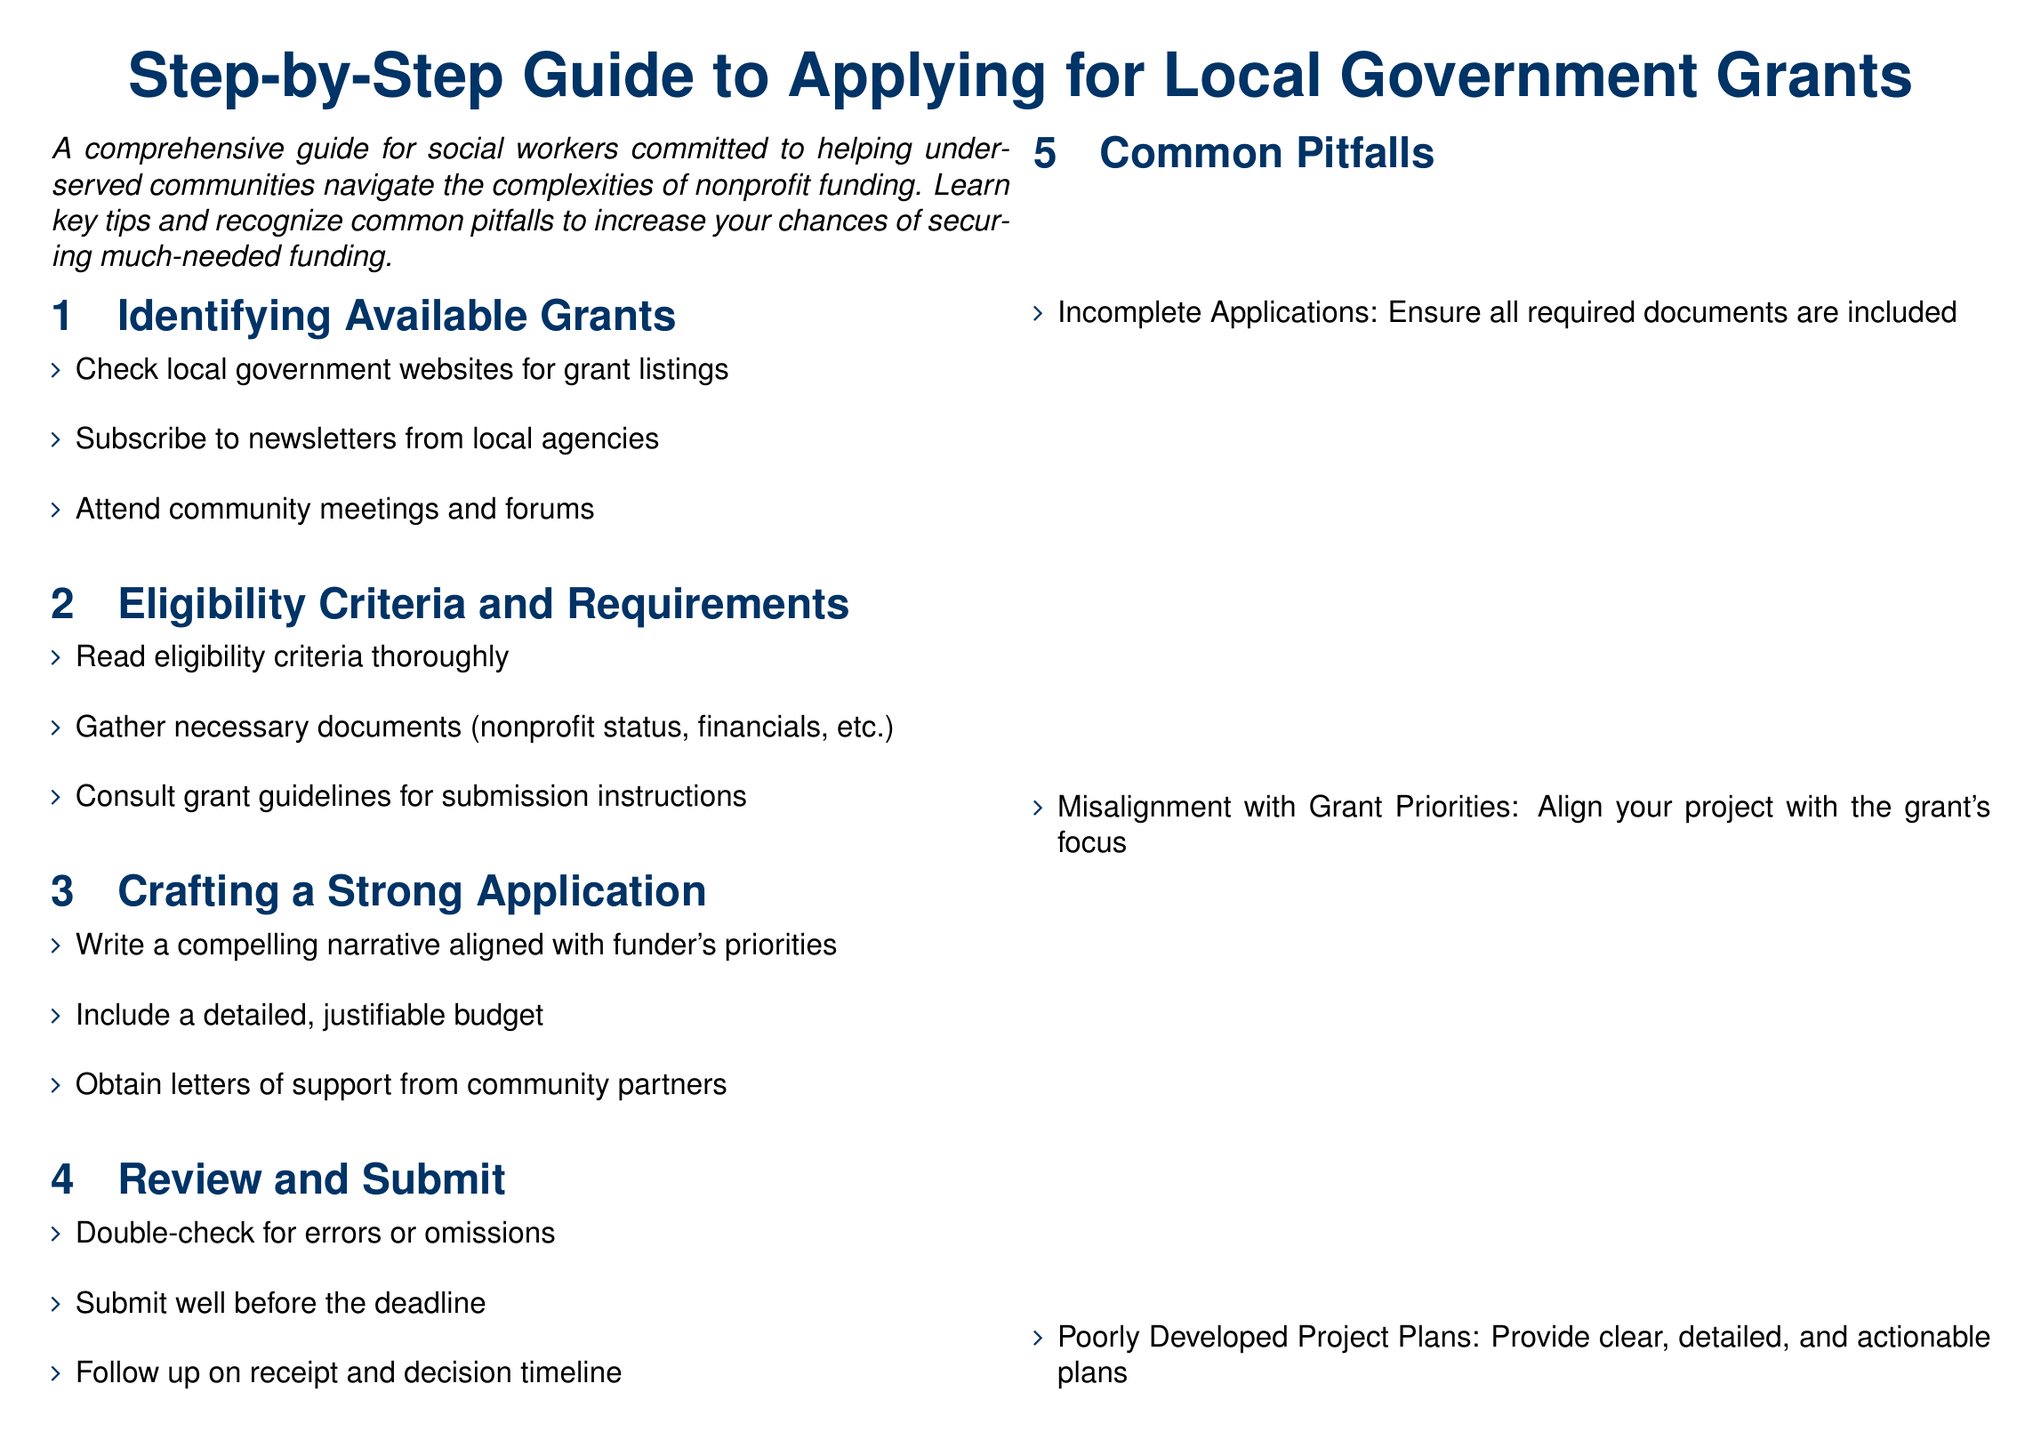What is the main purpose of this guide? The guide aims to assist social workers in navigating nonprofit funding complexities, particularly in securing local government grants.
Answer: To help underserved communities navigate nonprofit funding Where can you check for available grants? Available grants can be found on local government websites, as indicated in the document.
Answer: Local government websites What should you include in a strong application? A strong application should include a compelling narrative, a detailed budget, and letters of support.
Answer: Compelling narrative, detailed budget, letters of support What is a common pitfall when applying for grants? One common pitfall is submitting incomplete applications, which can lead to disqualification.
Answer: Incomplete Applications What is the suggested action before the deadline? The document advises submitting well before the deadline to allow for any issues that may arise.
Answer: Submit well before the deadline Which step involves reviewing for errors? The review process entails double-checking for errors or omissions before submission.
Answer: Review and Submit Who created this guide? The guide was created by a social worker committed to helping underserved communities.
Answer: A social worker What color is used for the main heading? The main heading is styled in dark blue.
Answer: Dark blue What is emphasized as crucial for applying successfully? Careful planning and attention to detail are emphasized as crucial for a successful application.
Answer: Careful planning and attention to detail 